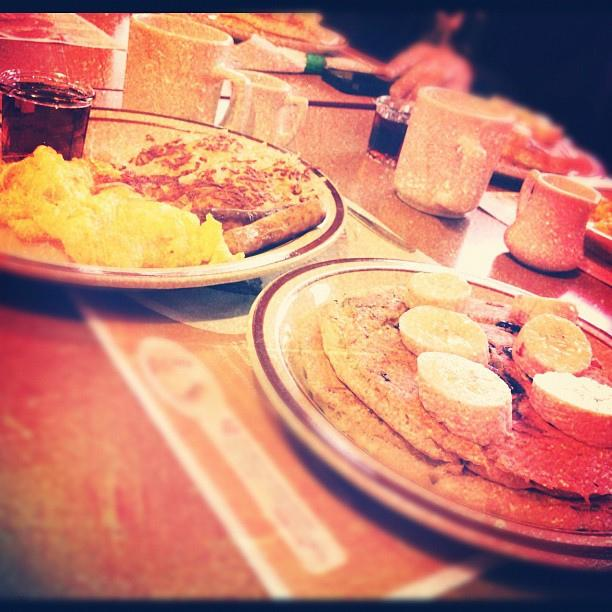What color are the fruits sliced out on top of the pancake?

Choices:
A) blue
B) pink
C) white
D) red white 